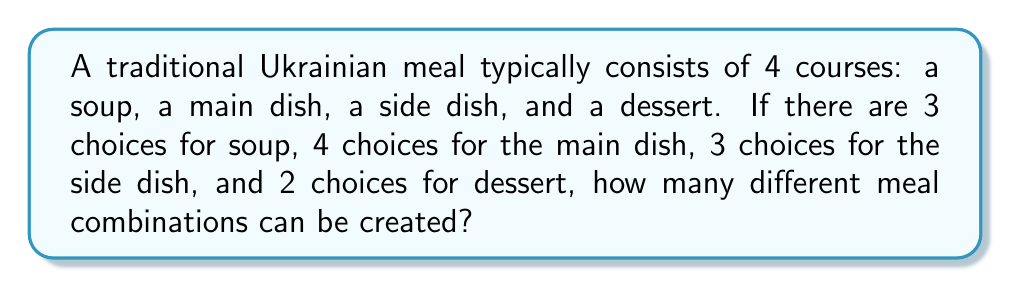Give your solution to this math problem. To solve this problem, we'll use the multiplication principle of counting. This principle states that if we have a sequence of choices, where the number of options for each choice is independent of the others, we multiply the number of options for each choice to get the total number of possible combinations.

Let's break it down step-by-step:

1. Soup choices: 3
2. Main dish choices: 4
3. Side dish choices: 3
4. Dessert choices: 2

To calculate the total number of combinations, we multiply these numbers together:

$$ \text{Total combinations} = 3 \times 4 \times 3 \times 2 $$

$$ = 72 $$

Therefore, there are 72 different possible combinations for creating a traditional Ukrainian meal with the given choices.
Answer: $72$ 